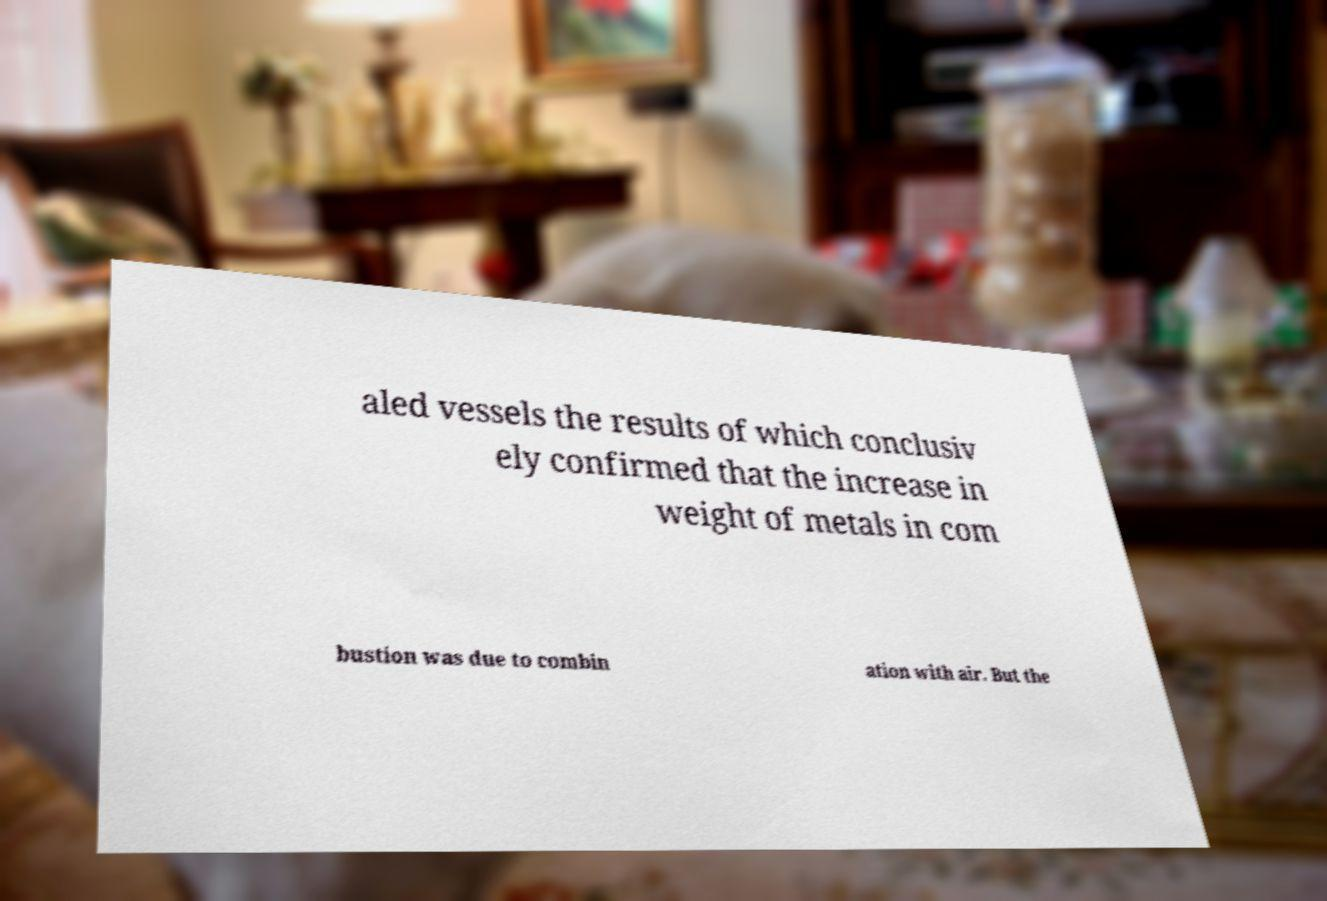Please identify and transcribe the text found in this image. aled vessels the results of which conclusiv ely confirmed that the increase in weight of metals in com bustion was due to combin ation with air. But the 